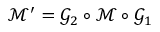Convert formula to latex. <formula><loc_0><loc_0><loc_500><loc_500>\mathcal { M } ^ { \prime } = \mathcal { G } _ { 2 } \circ \mathcal { M } \circ \mathcal { G } _ { 1 }</formula> 